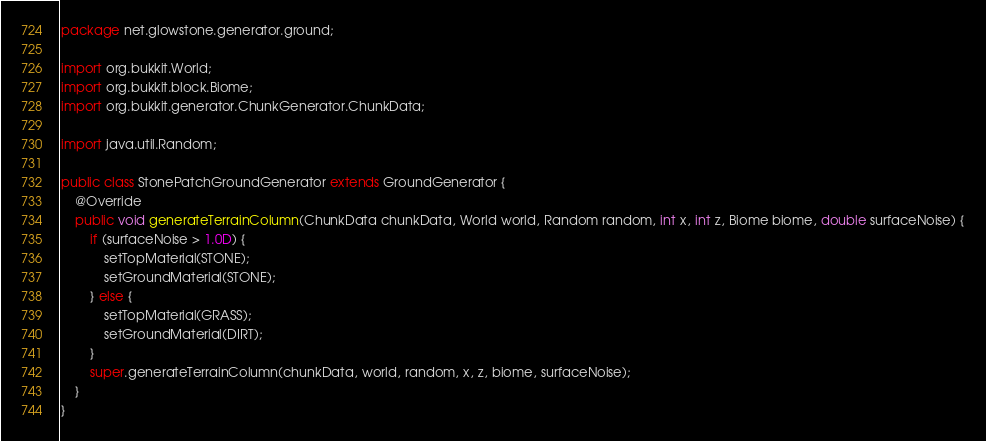Convert code to text. <code><loc_0><loc_0><loc_500><loc_500><_Java_>package net.glowstone.generator.ground;

import org.bukkit.World;
import org.bukkit.block.Biome;
import org.bukkit.generator.ChunkGenerator.ChunkData;

import java.util.Random;

public class StonePatchGroundGenerator extends GroundGenerator {
    @Override
    public void generateTerrainColumn(ChunkData chunkData, World world, Random random, int x, int z, Biome biome, double surfaceNoise) {
        if (surfaceNoise > 1.0D) {
            setTopMaterial(STONE);
            setGroundMaterial(STONE);
        } else {
            setTopMaterial(GRASS);
            setGroundMaterial(DIRT);
        }
        super.generateTerrainColumn(chunkData, world, random, x, z, biome, surfaceNoise);
    }
}
</code> 